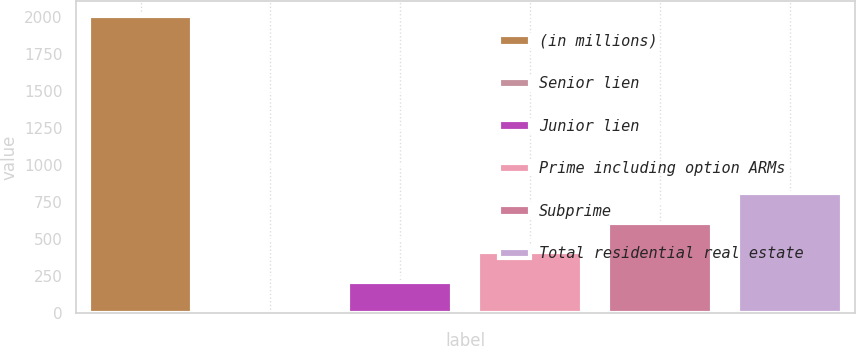<chart> <loc_0><loc_0><loc_500><loc_500><bar_chart><fcel>(in millions)<fcel>Senior lien<fcel>Junior lien<fcel>Prime including option ARMs<fcel>Subprime<fcel>Total residential real estate<nl><fcel>2012<fcel>12<fcel>212<fcel>412<fcel>612<fcel>812<nl></chart> 